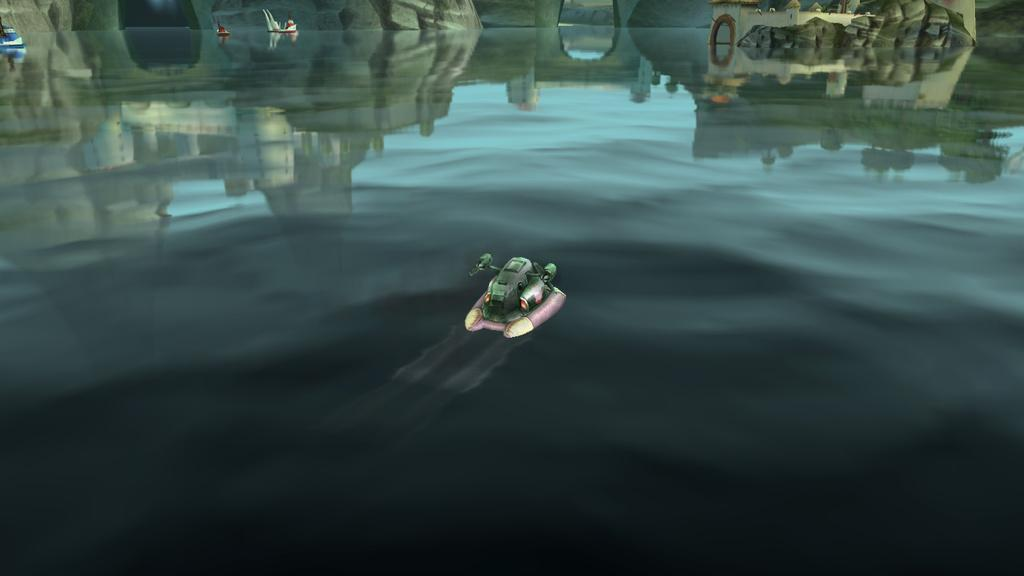What is the main subject of the image? The main subject of the image is a depiction of water. What can be seen in the water? There are boats in the water. What other structure is depicted in the image? There is a depiction of a building in the image. What type of memory is being used to store the image? The question refers to a concept that is not present in the image itself, as it focuses on the storage of the image rather than its content. Therefore, it cannot be answered definitively based on the provided facts. 